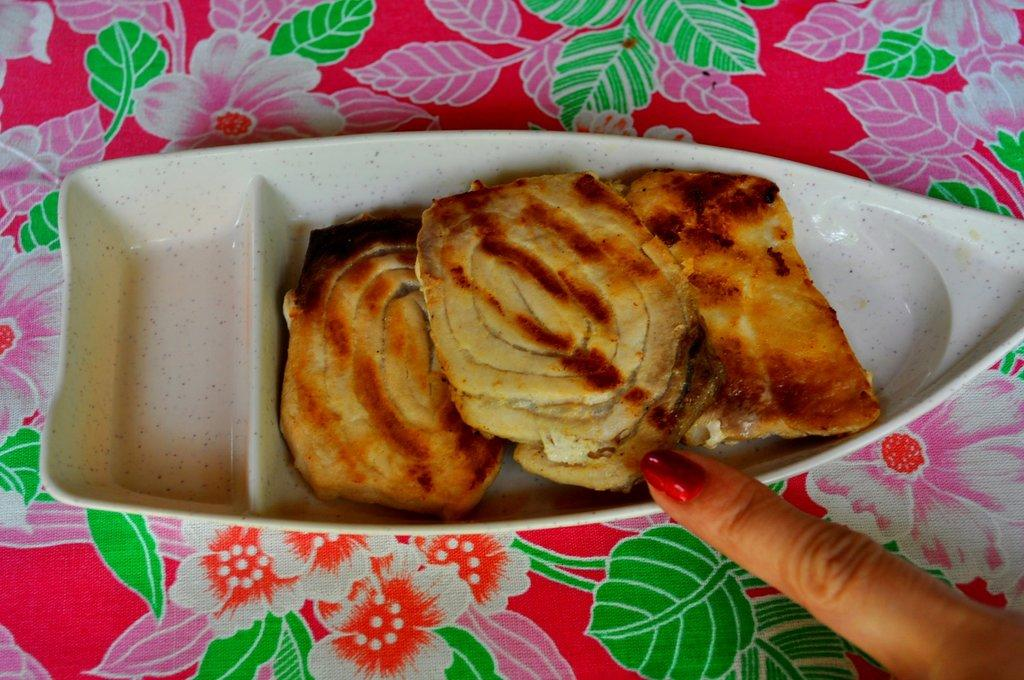What is placed on the object in the image? There are eatables placed on an object in the image. Can you describe the object on which the eatables are placed? The provided facts do not give information about the object on which the eatables are placed. Is there any indication of a person in the image? Yes, there is a finger of a person visible in the right bottom corner of the image. What type of plants can be seen growing in the jam in the image? There is no jam present in the image, and therefore no plants can be seen growing in it. 